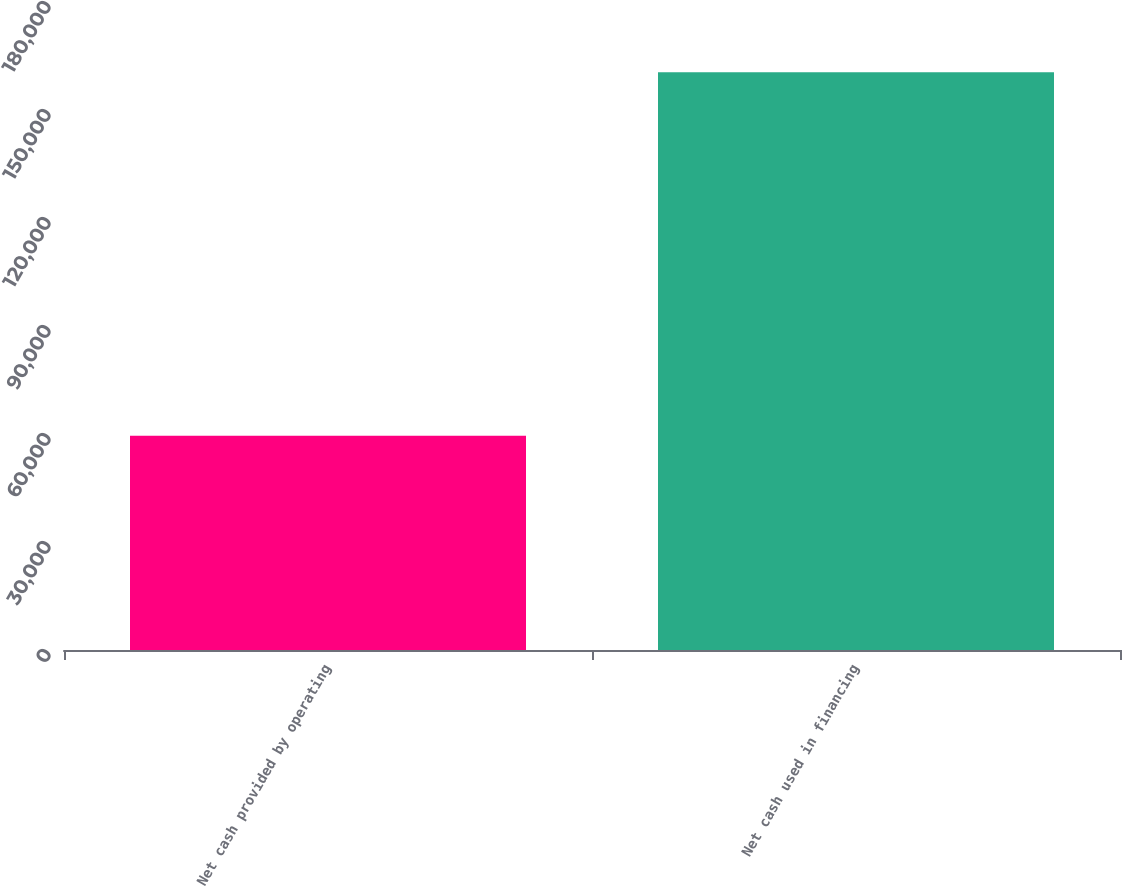<chart> <loc_0><loc_0><loc_500><loc_500><bar_chart><fcel>Net cash provided by operating<fcel>Net cash used in financing<nl><fcel>59522<fcel>160520<nl></chart> 